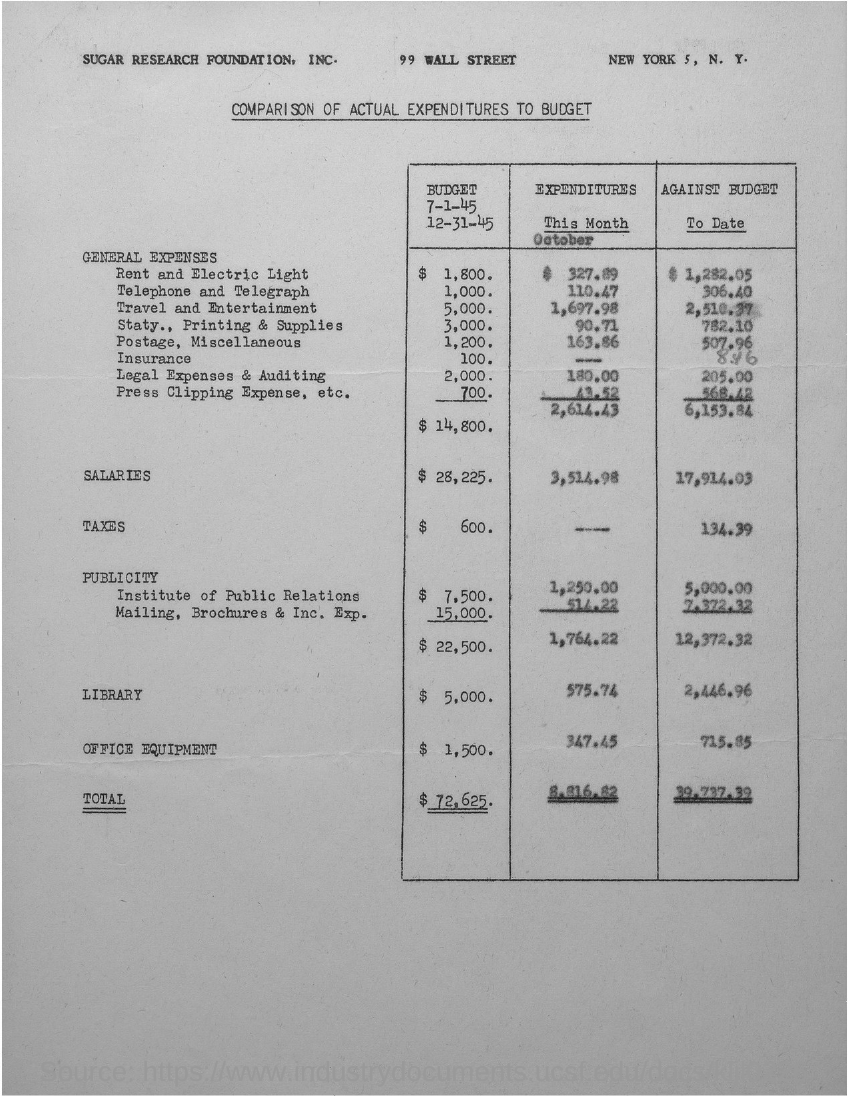Mention a couple of crucial points in this snapshot. The actual salary is 3,514.98. The total expenditure is 8,816.82. The actual expenditure for office equipment was 347.45... The actual expenditure for the library was $575.74. 